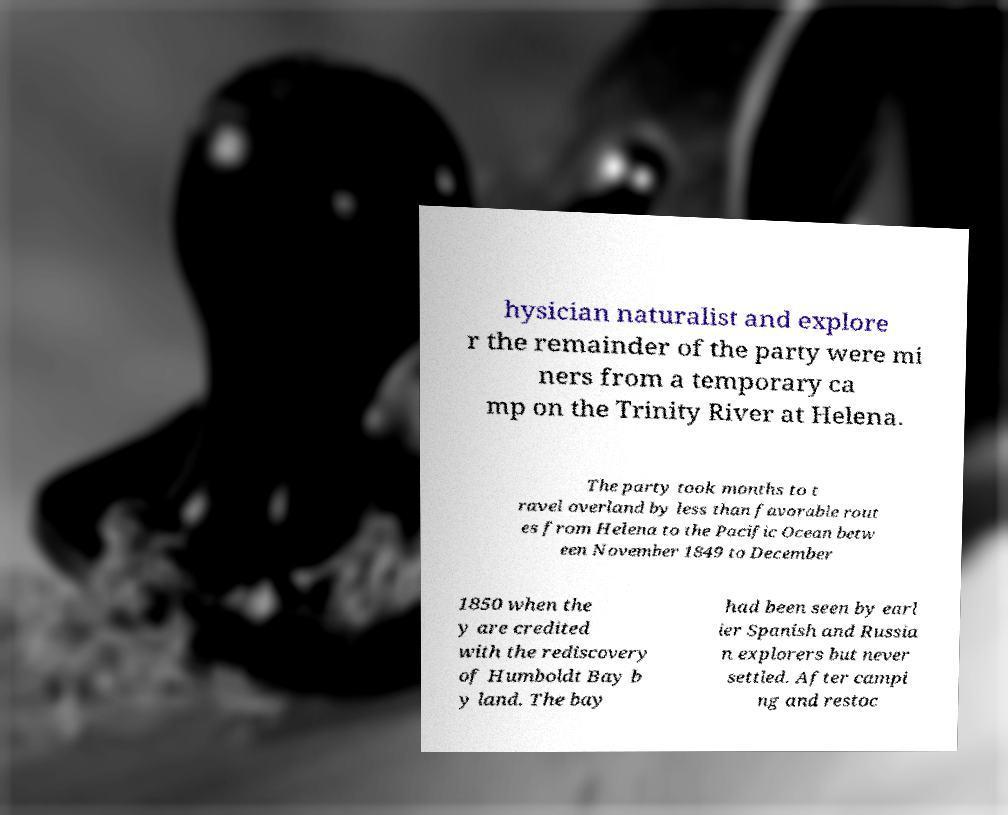Can you read and provide the text displayed in the image?This photo seems to have some interesting text. Can you extract and type it out for me? hysician naturalist and explore r the remainder of the party were mi ners from a temporary ca mp on the Trinity River at Helena. The party took months to t ravel overland by less than favorable rout es from Helena to the Pacific Ocean betw een November 1849 to December 1850 when the y are credited with the rediscovery of Humboldt Bay b y land. The bay had been seen by earl ier Spanish and Russia n explorers but never settled. After campi ng and restoc 